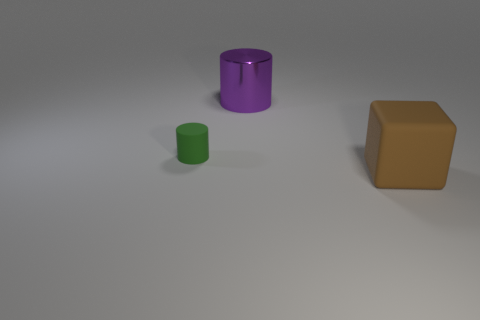What color is the small object that is the same shape as the large purple metallic thing?
Make the answer very short. Green. What material is the cylinder in front of the purple metal cylinder?
Your answer should be very brief. Rubber. The matte cylinder has what color?
Give a very brief answer. Green. Does the matte thing that is to the left of the brown block have the same size as the large purple metal thing?
Your response must be concise. No. What material is the green thing that is on the left side of the cylinder that is behind the matte object that is behind the big brown object?
Make the answer very short. Rubber. There is a large thing behind the object that is in front of the small thing; what is it made of?
Your response must be concise. Metal. The metallic object that is the same size as the brown block is what color?
Provide a short and direct response. Purple. There is a large brown object; is it the same shape as the big object to the left of the brown cube?
Your answer should be compact. No. What number of big brown cubes are on the right side of the rubber thing that is to the left of the matte thing on the right side of the metallic object?
Ensure brevity in your answer.  1. There is a rubber thing that is left of the large thing to the left of the brown cube; what size is it?
Your answer should be compact. Small. 